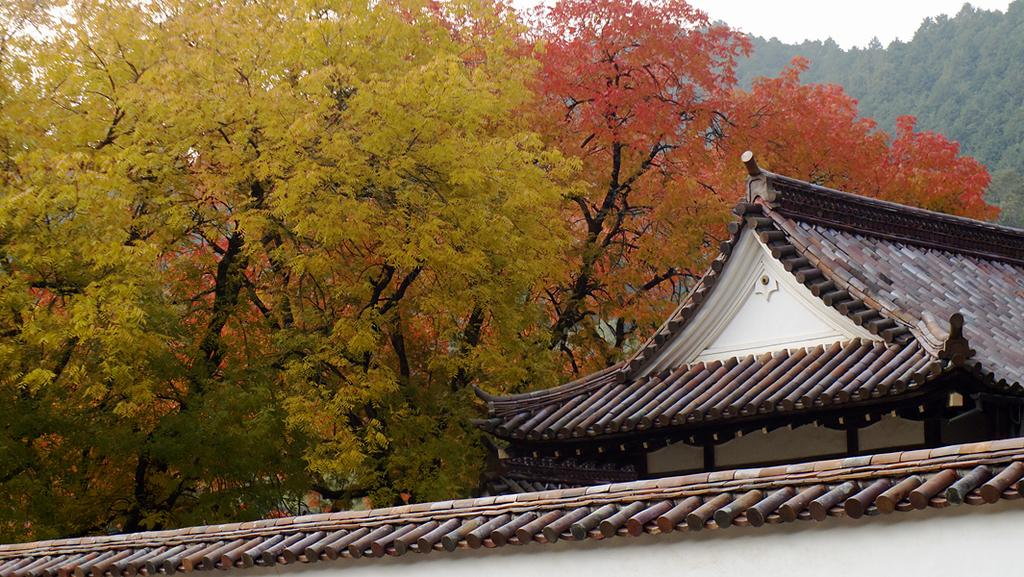What type of house is in the foreground of the image? There is a Japanese house in the foreground of the image. What can be seen in the background of the image? There are trees and the sky visible in the background of the image. Where is the sink located in the image? There is no sink present in the image. What impulse might the trees in the background have? The trees in the background are not capable of having impulses, as they are inanimate objects. 